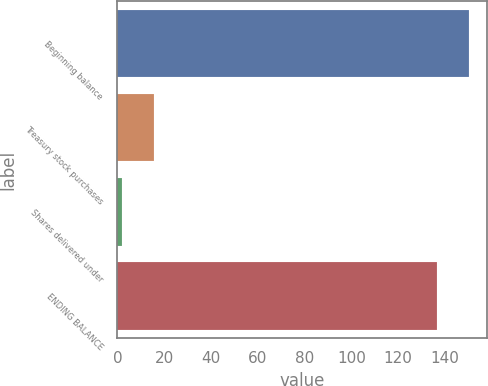<chart> <loc_0><loc_0><loc_500><loc_500><bar_chart><fcel>Beginning balance<fcel>Treasury stock purchases<fcel>Shares delivered under<fcel>ENDING BALANCE<nl><fcel>150.38<fcel>15.68<fcel>2<fcel>136.7<nl></chart> 